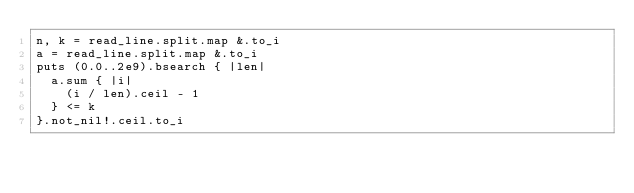Convert code to text. <code><loc_0><loc_0><loc_500><loc_500><_Crystal_>n, k = read_line.split.map &.to_i
a = read_line.split.map &.to_i
puts (0.0..2e9).bsearch { |len|
  a.sum { |i|
    (i / len).ceil - 1
  } <= k
}.not_nil!.ceil.to_i
</code> 